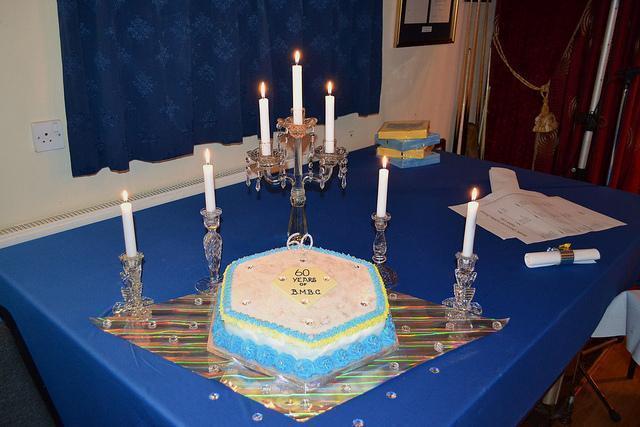How many candles are in this picture?
Give a very brief answer. 7. How many hot dogs are there?
Give a very brief answer. 0. 